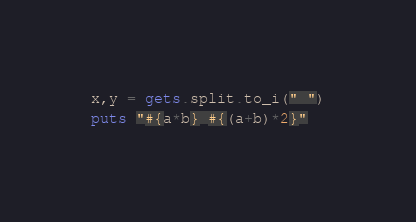Convert code to text. <code><loc_0><loc_0><loc_500><loc_500><_Ruby_>x,y = gets.split.to_i(" ")
puts "#{a*b} #{(a+b)*2}"</code> 